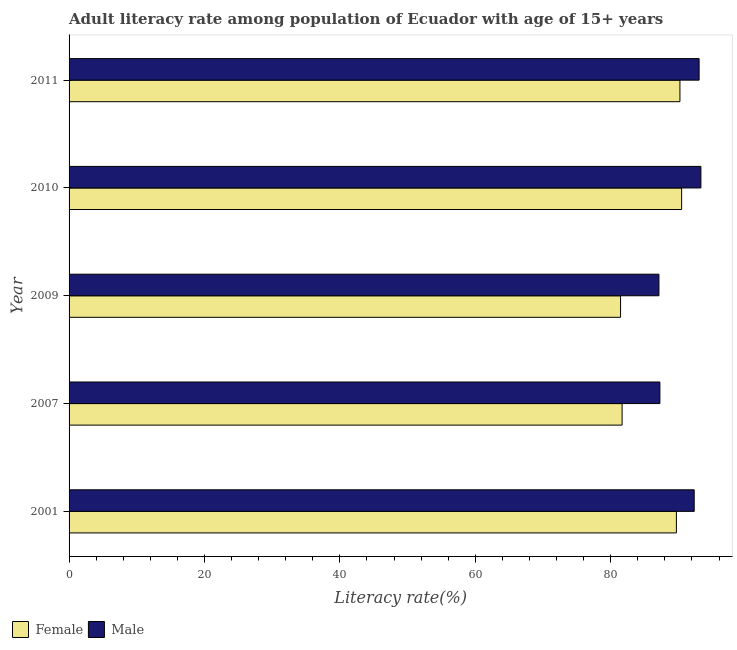Are the number of bars on each tick of the Y-axis equal?
Provide a succinct answer. Yes. How many bars are there on the 2nd tick from the top?
Offer a terse response. 2. What is the label of the 1st group of bars from the top?
Ensure brevity in your answer.  2011. What is the male adult literacy rate in 2011?
Offer a terse response. 93.05. Across all years, what is the maximum female adult literacy rate?
Provide a short and direct response. 90.47. Across all years, what is the minimum male adult literacy rate?
Your answer should be very brief. 87.12. In which year was the male adult literacy rate maximum?
Your answer should be very brief. 2010. What is the total male adult literacy rate in the graph?
Ensure brevity in your answer.  453.07. What is the difference between the female adult literacy rate in 2001 and that in 2010?
Provide a succinct answer. -0.77. What is the difference between the female adult literacy rate in 2009 and the male adult literacy rate in 2007?
Your answer should be very brief. -5.81. What is the average male adult literacy rate per year?
Make the answer very short. 90.61. In the year 2010, what is the difference between the female adult literacy rate and male adult literacy rate?
Ensure brevity in your answer.  -2.85. What is the ratio of the female adult literacy rate in 2001 to that in 2010?
Your response must be concise. 0.99. What is the difference between the highest and the second highest male adult literacy rate?
Make the answer very short. 0.26. What is the difference between the highest and the lowest female adult literacy rate?
Ensure brevity in your answer.  9.02. In how many years, is the male adult literacy rate greater than the average male adult literacy rate taken over all years?
Provide a succinct answer. 3. Is the sum of the female adult literacy rate in 2001 and 2010 greater than the maximum male adult literacy rate across all years?
Ensure brevity in your answer.  Yes. What does the 1st bar from the bottom in 2007 represents?
Your answer should be very brief. Female. What is the difference between two consecutive major ticks on the X-axis?
Your answer should be compact. 20. Are the values on the major ticks of X-axis written in scientific E-notation?
Your answer should be very brief. No. How many legend labels are there?
Provide a succinct answer. 2. How are the legend labels stacked?
Your answer should be compact. Horizontal. What is the title of the graph?
Provide a succinct answer. Adult literacy rate among population of Ecuador with age of 15+ years. What is the label or title of the X-axis?
Ensure brevity in your answer.  Literacy rate(%). What is the label or title of the Y-axis?
Provide a succinct answer. Year. What is the Literacy rate(%) of Female in 2001?
Ensure brevity in your answer.  89.7. What is the Literacy rate(%) of Male in 2001?
Offer a very short reply. 92.33. What is the Literacy rate(%) in Female in 2007?
Offer a very short reply. 81.68. What is the Literacy rate(%) in Male in 2007?
Offer a terse response. 87.26. What is the Literacy rate(%) of Female in 2009?
Your answer should be compact. 81.45. What is the Literacy rate(%) of Male in 2009?
Make the answer very short. 87.12. What is the Literacy rate(%) of Female in 2010?
Provide a short and direct response. 90.47. What is the Literacy rate(%) of Male in 2010?
Offer a terse response. 93.32. What is the Literacy rate(%) in Female in 2011?
Make the answer very short. 90.22. What is the Literacy rate(%) of Male in 2011?
Your response must be concise. 93.05. Across all years, what is the maximum Literacy rate(%) in Female?
Provide a succinct answer. 90.47. Across all years, what is the maximum Literacy rate(%) of Male?
Your response must be concise. 93.32. Across all years, what is the minimum Literacy rate(%) of Female?
Keep it short and to the point. 81.45. Across all years, what is the minimum Literacy rate(%) in Male?
Keep it short and to the point. 87.12. What is the total Literacy rate(%) of Female in the graph?
Keep it short and to the point. 433.52. What is the total Literacy rate(%) in Male in the graph?
Offer a terse response. 453.07. What is the difference between the Literacy rate(%) of Female in 2001 and that in 2007?
Make the answer very short. 8.02. What is the difference between the Literacy rate(%) in Male in 2001 and that in 2007?
Offer a very short reply. 5.07. What is the difference between the Literacy rate(%) in Female in 2001 and that in 2009?
Provide a short and direct response. 8.25. What is the difference between the Literacy rate(%) in Male in 2001 and that in 2009?
Make the answer very short. 5.21. What is the difference between the Literacy rate(%) in Female in 2001 and that in 2010?
Your response must be concise. -0.77. What is the difference between the Literacy rate(%) in Male in 2001 and that in 2010?
Offer a very short reply. -0.99. What is the difference between the Literacy rate(%) of Female in 2001 and that in 2011?
Your answer should be compact. -0.52. What is the difference between the Literacy rate(%) of Male in 2001 and that in 2011?
Ensure brevity in your answer.  -0.73. What is the difference between the Literacy rate(%) in Female in 2007 and that in 2009?
Your response must be concise. 0.23. What is the difference between the Literacy rate(%) in Male in 2007 and that in 2009?
Keep it short and to the point. 0.14. What is the difference between the Literacy rate(%) in Female in 2007 and that in 2010?
Your response must be concise. -8.79. What is the difference between the Literacy rate(%) in Male in 2007 and that in 2010?
Offer a very short reply. -6.06. What is the difference between the Literacy rate(%) in Female in 2007 and that in 2011?
Offer a very short reply. -8.54. What is the difference between the Literacy rate(%) in Male in 2007 and that in 2011?
Make the answer very short. -5.79. What is the difference between the Literacy rate(%) in Female in 2009 and that in 2010?
Offer a terse response. -9.02. What is the difference between the Literacy rate(%) of Male in 2009 and that in 2010?
Offer a terse response. -6.2. What is the difference between the Literacy rate(%) of Female in 2009 and that in 2011?
Provide a short and direct response. -8.77. What is the difference between the Literacy rate(%) in Male in 2009 and that in 2011?
Provide a succinct answer. -5.93. What is the difference between the Literacy rate(%) of Female in 2010 and that in 2011?
Your answer should be compact. 0.25. What is the difference between the Literacy rate(%) of Male in 2010 and that in 2011?
Give a very brief answer. 0.26. What is the difference between the Literacy rate(%) in Female in 2001 and the Literacy rate(%) in Male in 2007?
Provide a succinct answer. 2.44. What is the difference between the Literacy rate(%) in Female in 2001 and the Literacy rate(%) in Male in 2009?
Provide a short and direct response. 2.58. What is the difference between the Literacy rate(%) of Female in 2001 and the Literacy rate(%) of Male in 2010?
Keep it short and to the point. -3.62. What is the difference between the Literacy rate(%) in Female in 2001 and the Literacy rate(%) in Male in 2011?
Make the answer very short. -3.36. What is the difference between the Literacy rate(%) in Female in 2007 and the Literacy rate(%) in Male in 2009?
Your answer should be very brief. -5.44. What is the difference between the Literacy rate(%) in Female in 2007 and the Literacy rate(%) in Male in 2010?
Offer a very short reply. -11.64. What is the difference between the Literacy rate(%) of Female in 2007 and the Literacy rate(%) of Male in 2011?
Your answer should be compact. -11.37. What is the difference between the Literacy rate(%) of Female in 2009 and the Literacy rate(%) of Male in 2010?
Provide a short and direct response. -11.87. What is the difference between the Literacy rate(%) of Female in 2009 and the Literacy rate(%) of Male in 2011?
Your response must be concise. -11.6. What is the difference between the Literacy rate(%) of Female in 2010 and the Literacy rate(%) of Male in 2011?
Offer a terse response. -2.58. What is the average Literacy rate(%) of Female per year?
Offer a terse response. 86.7. What is the average Literacy rate(%) in Male per year?
Provide a succinct answer. 90.61. In the year 2001, what is the difference between the Literacy rate(%) of Female and Literacy rate(%) of Male?
Give a very brief answer. -2.63. In the year 2007, what is the difference between the Literacy rate(%) of Female and Literacy rate(%) of Male?
Give a very brief answer. -5.58. In the year 2009, what is the difference between the Literacy rate(%) of Female and Literacy rate(%) of Male?
Ensure brevity in your answer.  -5.67. In the year 2010, what is the difference between the Literacy rate(%) of Female and Literacy rate(%) of Male?
Provide a succinct answer. -2.85. In the year 2011, what is the difference between the Literacy rate(%) of Female and Literacy rate(%) of Male?
Offer a very short reply. -2.83. What is the ratio of the Literacy rate(%) of Female in 2001 to that in 2007?
Give a very brief answer. 1.1. What is the ratio of the Literacy rate(%) in Male in 2001 to that in 2007?
Provide a succinct answer. 1.06. What is the ratio of the Literacy rate(%) of Female in 2001 to that in 2009?
Provide a succinct answer. 1.1. What is the ratio of the Literacy rate(%) in Male in 2001 to that in 2009?
Offer a very short reply. 1.06. What is the ratio of the Literacy rate(%) of Male in 2007 to that in 2009?
Provide a succinct answer. 1. What is the ratio of the Literacy rate(%) in Female in 2007 to that in 2010?
Keep it short and to the point. 0.9. What is the ratio of the Literacy rate(%) of Male in 2007 to that in 2010?
Keep it short and to the point. 0.94. What is the ratio of the Literacy rate(%) of Female in 2007 to that in 2011?
Provide a succinct answer. 0.91. What is the ratio of the Literacy rate(%) of Male in 2007 to that in 2011?
Give a very brief answer. 0.94. What is the ratio of the Literacy rate(%) in Female in 2009 to that in 2010?
Provide a succinct answer. 0.9. What is the ratio of the Literacy rate(%) of Male in 2009 to that in 2010?
Offer a terse response. 0.93. What is the ratio of the Literacy rate(%) of Female in 2009 to that in 2011?
Offer a very short reply. 0.9. What is the ratio of the Literacy rate(%) of Male in 2009 to that in 2011?
Your response must be concise. 0.94. What is the ratio of the Literacy rate(%) of Female in 2010 to that in 2011?
Keep it short and to the point. 1. What is the difference between the highest and the second highest Literacy rate(%) in Female?
Provide a succinct answer. 0.25. What is the difference between the highest and the second highest Literacy rate(%) of Male?
Ensure brevity in your answer.  0.26. What is the difference between the highest and the lowest Literacy rate(%) in Female?
Offer a very short reply. 9.02. What is the difference between the highest and the lowest Literacy rate(%) of Male?
Provide a short and direct response. 6.2. 